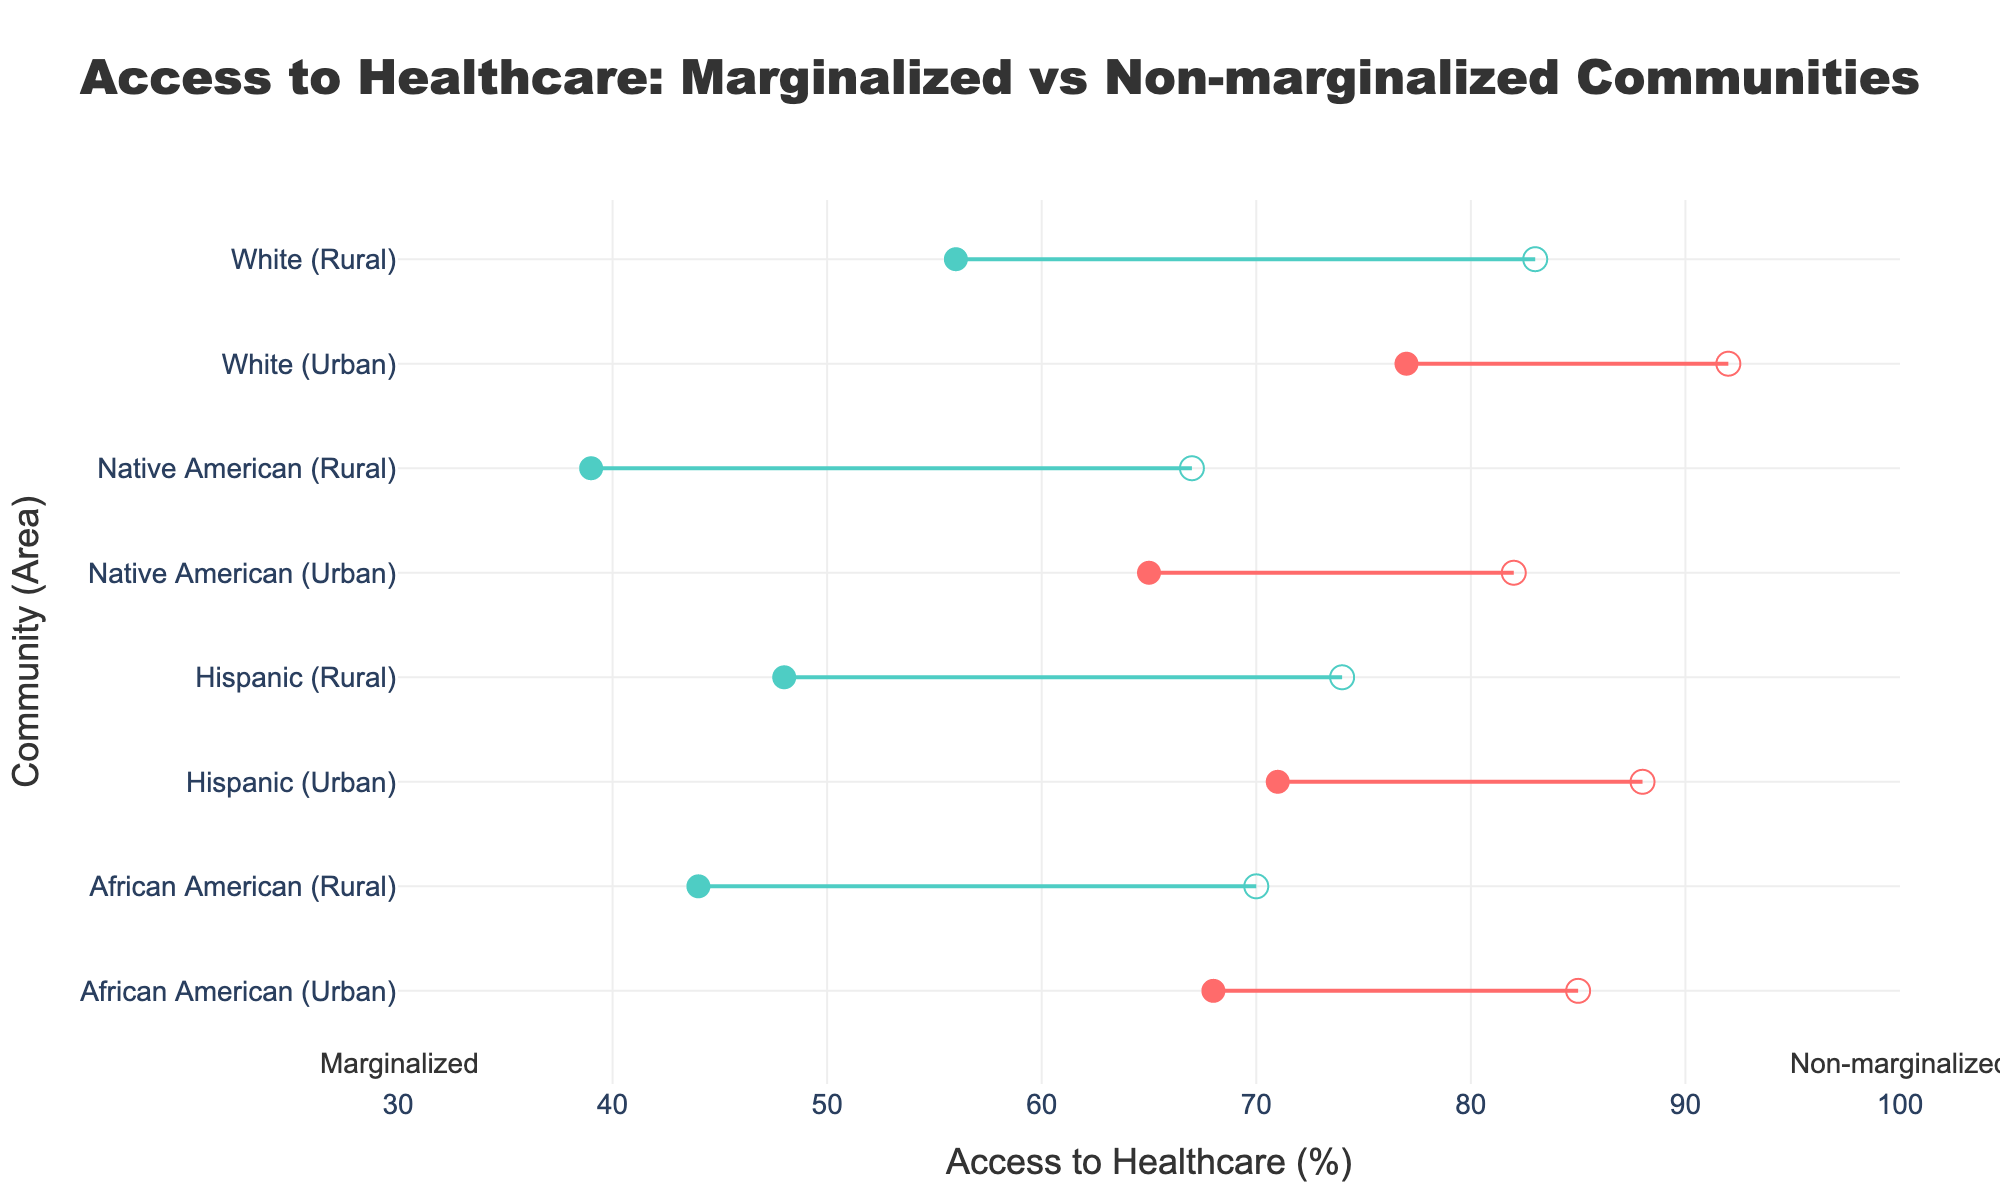How does the access to healthcare for marginalized Native American communities in rural areas compare to non-marginalized Hispanic communities in rural areas? Access to healthcare for marginalized Native American communities in rural areas is 39%. For non-marginalized Hispanic communities in rural areas, it is 74%.
Answer: 35% What is the difference in access to healthcare between marginalized and non-marginalized African Americans in urban areas? Marginalized African Americans in urban areas have 68% access to healthcare, while non-marginalized African Americans have 85%. The difference is 85% - 68% = 17%.
Answer: 17% Which community and area combination has the highest access to healthcare for marginalized groups? Examining all marginalized groups, marginalized White communities in urban areas have the highest access to healthcare at 77%.
Answer: White (Urban) What is the average access to healthcare for marginalized communities in rural areas across all available communities? Marginalized African American (44%), Hispanic (48%), Native American (39%), and White (56%) communities in rural areas. The average is (44 + 48 + 39 + 56) / 4 = 46.75%.
Answer: 46.75% How does the access to healthcare for marginalized Hispanic communities in urban areas compare to non-marginalized Native American communities in urban areas? Marginalized Hispanic communities in urban areas have 71% access, while non-marginalized Native American communities in urban areas have 82%.
Answer: 11% Which community shows the largest disparity in access to healthcare between its marginalized and non-marginalized groups? Comparing all disparities: African American (Urban: 85-68=17, Rural: 70-44=26), Hispanic (Urban: 88-71=17, Rural: 74-48=26), Native American (Urban: 82-65=17, Rural: 67-39=28), White (Urban: 92-77=15, Rural: 83-56=27). Native American (Rural) has the largest disparity at 28%.
Answer: Native American (Rural) Which area shows a greater disparity in access to healthcare between marginalized and non-marginalized groups on average, urban or rural? For urban areas: African American (85-68=17), Hispanic (88-71=17), Native American (82-65=17), White (92-77=15). Average = (17+17+17+15)/4 = 16.5. For rural areas: African American (70-44=26), Hispanic (74-48=26), Native American (67-39=28), White (83-56=27). Average = (26+26+28+27)/4 = 26.75. Therefore, rural areas show a greater disparity.
Answer: Rural How does the access to healthcare for non-marginalized African American communities in rural areas compare to marginalized White communities in the same areas? Non-marginalized African American communities in rural areas have 70% access, while marginalized White communities in rural areas have 56%.
Answer: 14% Which community and area combination has the lowest access to healthcare for non-marginalized groups? Observing non-marginalized groups, non-marginalized Native American communities in rural areas have the lowest access to healthcare at 67%.
Answer: Native American (Rural) 